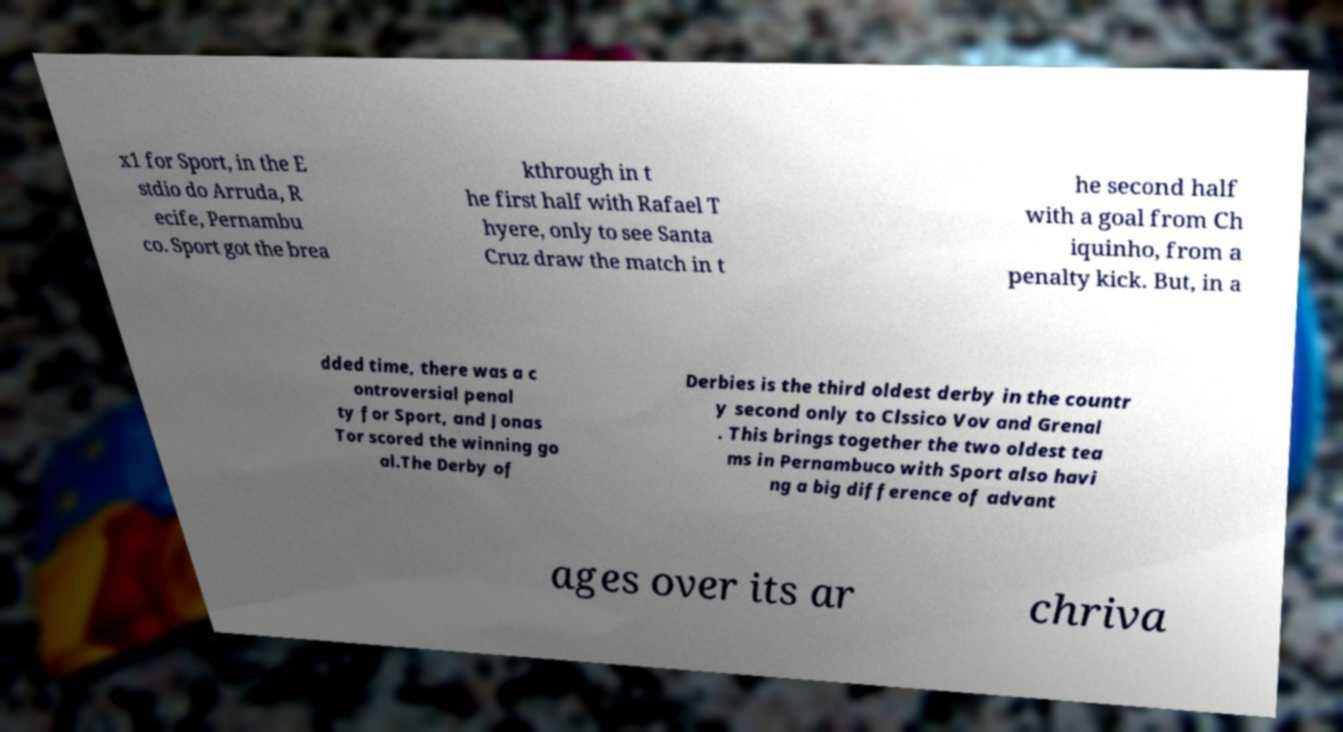There's text embedded in this image that I need extracted. Can you transcribe it verbatim? x1 for Sport, in the E stdio do Arruda, R ecife, Pernambu co. Sport got the brea kthrough in t he first half with Rafael T hyere, only to see Santa Cruz draw the match in t he second half with a goal from Ch iquinho, from a penalty kick. But, in a dded time, there was a c ontroversial penal ty for Sport, and Jonas Tor scored the winning go al.The Derby of Derbies is the third oldest derby in the countr y second only to Clssico Vov and Grenal . This brings together the two oldest tea ms in Pernambuco with Sport also havi ng a big difference of advant ages over its ar chriva 